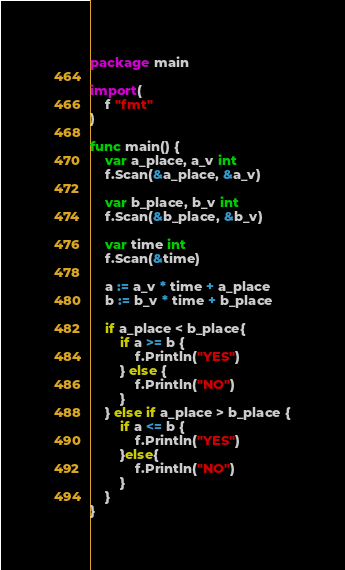<code> <loc_0><loc_0><loc_500><loc_500><_Go_>package main

import(
	f "fmt"
)

func main() {
	var a_place, a_v int
	f.Scan(&a_place, &a_v)

	var b_place, b_v int
	f.Scan(&b_place, &b_v)

	var time int
	f.Scan(&time)

	a := a_v * time + a_place
	b := b_v * time + b_place

	if a_place < b_place{
		if a >= b {
			f.Println("YES")
		} else {
			f.Println("NO")
		}
	} else if a_place > b_place {
		if a <= b {
			f.Println("YES")
		}else{
			f.Println("NO")
		}
	}
}</code> 